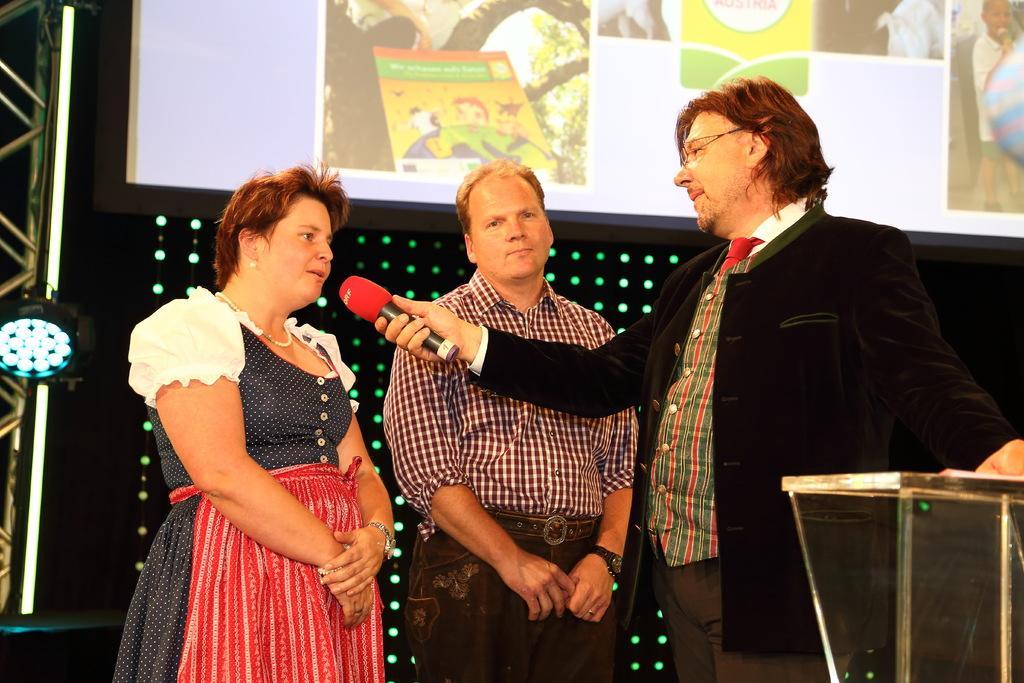Could you give a brief overview of what you see in this image? In the picture there are two men and a woman standing, one man is holding a microphone, there is a podium, behind them there may be lights and there is a screen. 